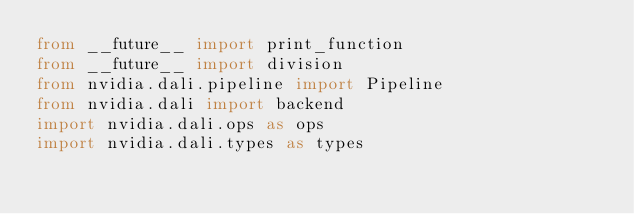<code> <loc_0><loc_0><loc_500><loc_500><_Python_>from __future__ import print_function
from __future__ import division
from nvidia.dali.pipeline import Pipeline
from nvidia.dali import backend
import nvidia.dali.ops as ops
import nvidia.dali.types as types</code> 